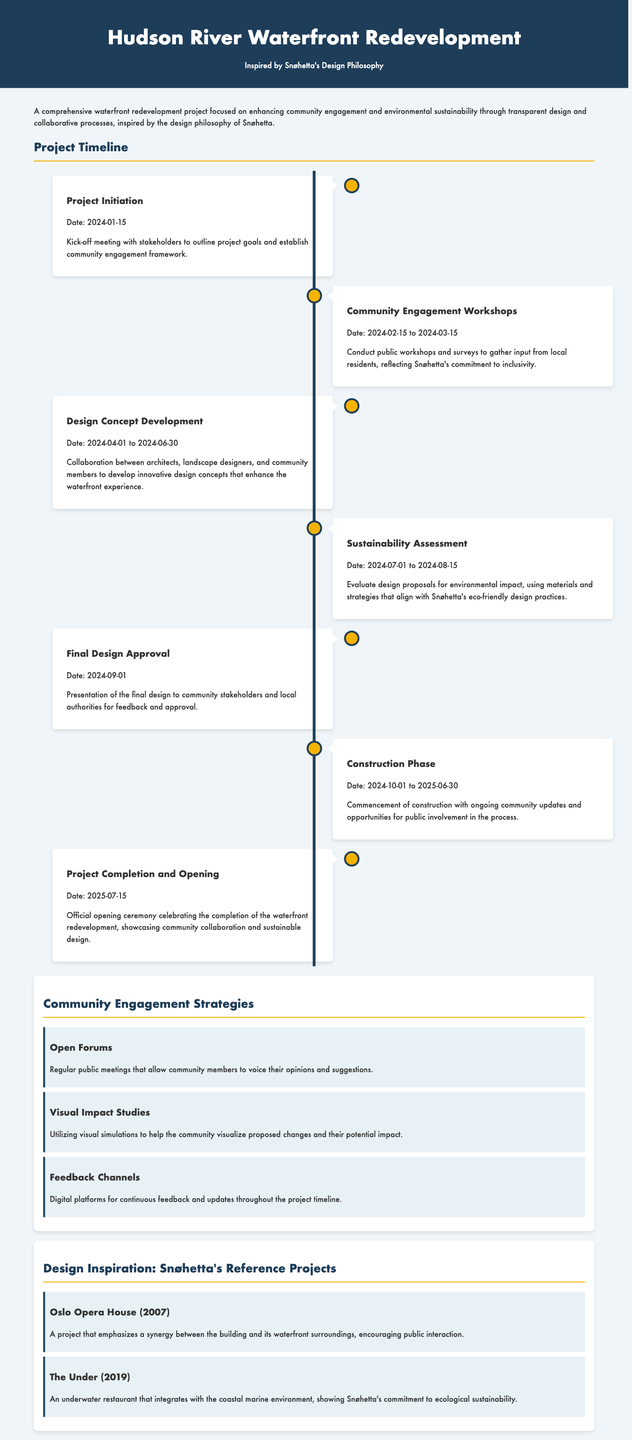What is the date of the project initiation? The project initiation is marked by a specific date listed in the timeline.
Answer: 2024-01-15 What are the dates for the community engagement workshops? The community engagement workshops span a range of dates identified in the document.
Answer: 2024-02-15 to 2024-03-15 What milestone follows the sustainability assessment? The order of milestones is chronological, making it possible to identify the next step in the timeline.
Answer: Final Design Approval What is one of the community engagement strategies mentioned? The document lists various strategies for community engagement, highlighting specific methods used.
Answer: Open Forums What is the project completion date? The official completion date is explicitly stated as the closing milestone in the timeline.
Answer: 2025-07-15 Which project by Snøhetta is referenced as completed in 2007? The document provides specific projects that serve as design inspiration, including their completion years.
Answer: Oslo Opera House What type of meetings facilitates community feedback? The document details various formats for engaging the community in discussions about the project.
Answer: Public meetings What is emphasized in the project philosophy? The document highlights the core themes and values that guide the project’s approach to design and community involvement.
Answer: Transparency and community engagement 